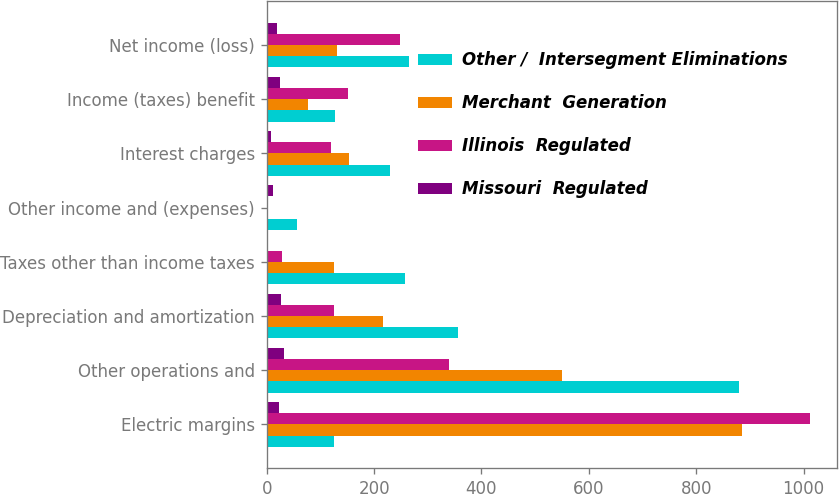Convert chart. <chart><loc_0><loc_0><loc_500><loc_500><stacked_bar_chart><ecel><fcel>Electric margins<fcel>Other operations and<fcel>Depreciation and amortization<fcel>Taxes other than income taxes<fcel>Other income and (expenses)<fcel>Interest charges<fcel>Income (taxes) benefit<fcel>Net income (loss)<nl><fcel>Other /  Intersegment Eliminations<fcel>126<fcel>880<fcel>357<fcel>257<fcel>56<fcel>229<fcel>128<fcel>265<nl><fcel>Merchant  Generation<fcel>886<fcel>550<fcel>216<fcel>125<fcel>2<fcel>153<fcel>77<fcel>130<nl><fcel>Illinois  Regulated<fcel>1012<fcel>340<fcel>126<fcel>28<fcel>1<fcel>119<fcel>151<fcel>249<nl><fcel>Missouri  Regulated<fcel>22<fcel>32<fcel>26<fcel>2<fcel>11<fcel>7<fcel>24<fcel>20<nl></chart> 